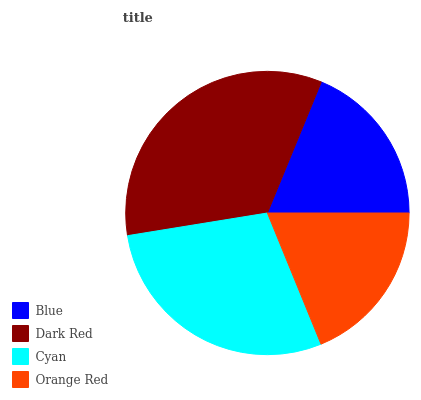Is Blue the minimum?
Answer yes or no. Yes. Is Dark Red the maximum?
Answer yes or no. Yes. Is Cyan the minimum?
Answer yes or no. No. Is Cyan the maximum?
Answer yes or no. No. Is Dark Red greater than Cyan?
Answer yes or no. Yes. Is Cyan less than Dark Red?
Answer yes or no. Yes. Is Cyan greater than Dark Red?
Answer yes or no. No. Is Dark Red less than Cyan?
Answer yes or no. No. Is Cyan the high median?
Answer yes or no. Yes. Is Orange Red the low median?
Answer yes or no. Yes. Is Dark Red the high median?
Answer yes or no. No. Is Cyan the low median?
Answer yes or no. No. 